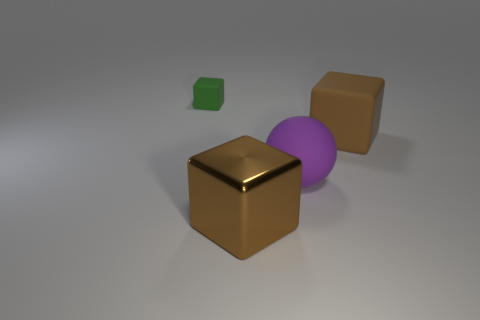Add 2 small red cylinders. How many objects exist? 6 Subtract all blocks. How many objects are left? 1 Subtract 2 brown cubes. How many objects are left? 2 Subtract all big brown rubber cubes. Subtract all big shiny things. How many objects are left? 2 Add 4 metal cubes. How many metal cubes are left? 5 Add 3 shiny things. How many shiny things exist? 4 